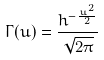Convert formula to latex. <formula><loc_0><loc_0><loc_500><loc_500>\Gamma ( u ) = \frac { h ^ { - \frac { u ^ { 2 } } { 2 } } } { \sqrt { 2 \pi } }</formula> 